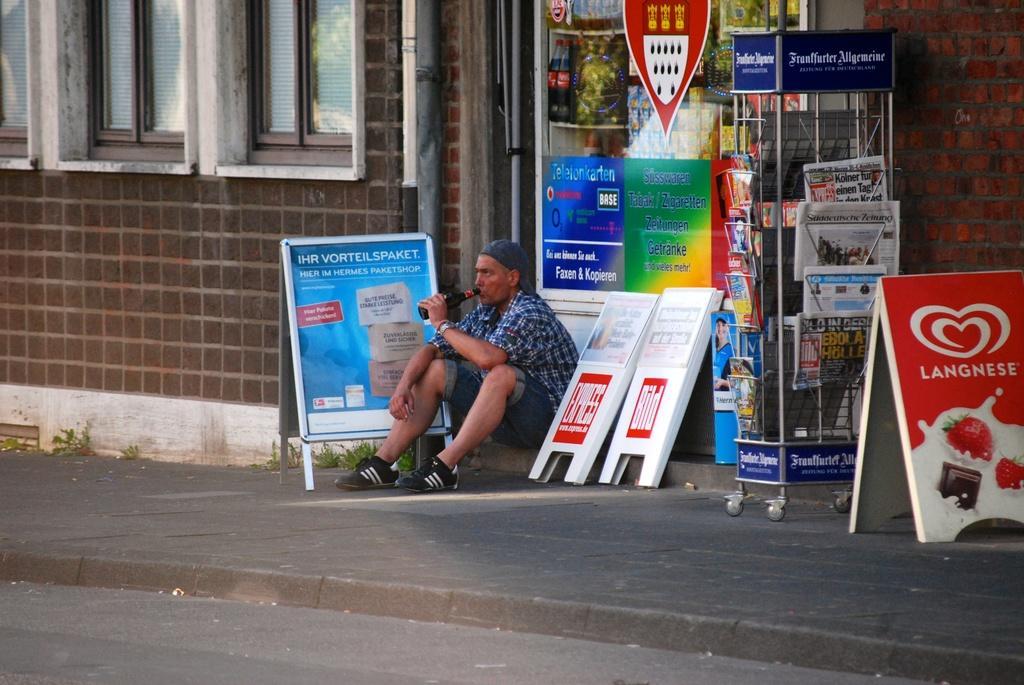In one or two sentences, can you explain what this image depicts? In this image there is a person sitting on the pavement is drinking, beside the person there are posters on boards and there is a paper stand with papers, behind the person there is a wall with windows, in front of the person there is pavement. 